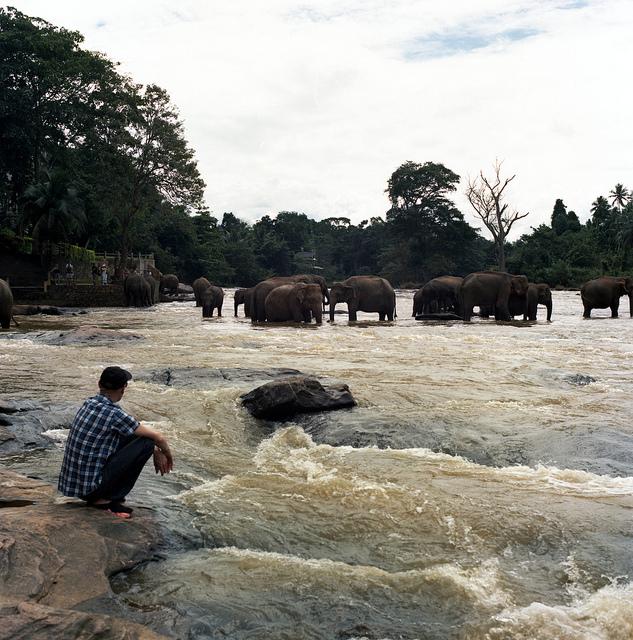Is the man far from the elephants?
Give a very brief answer. No. Are the animals swimming?
Short answer required. No. What kind of animals are those?
Write a very short answer. Elephants. Have these bushes been trimmed?
Keep it brief. No. 